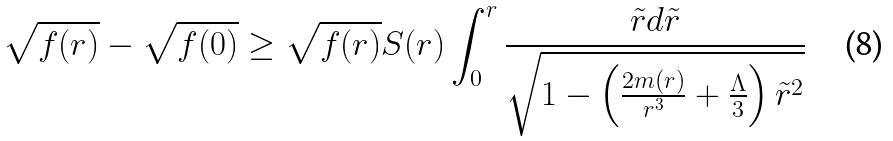<formula> <loc_0><loc_0><loc_500><loc_500>\sqrt { f ( r ) } - \sqrt { f ( 0 ) } \geq \sqrt { f ( r ) } S ( r ) \int _ { 0 } ^ { r } \frac { \tilde { r } d \tilde { r } } { \sqrt { 1 - \left ( \frac { 2 m ( r ) } { r ^ { 3 } } + \frac { \Lambda } { 3 } \right ) \tilde { r } ^ { 2 } } }</formula> 